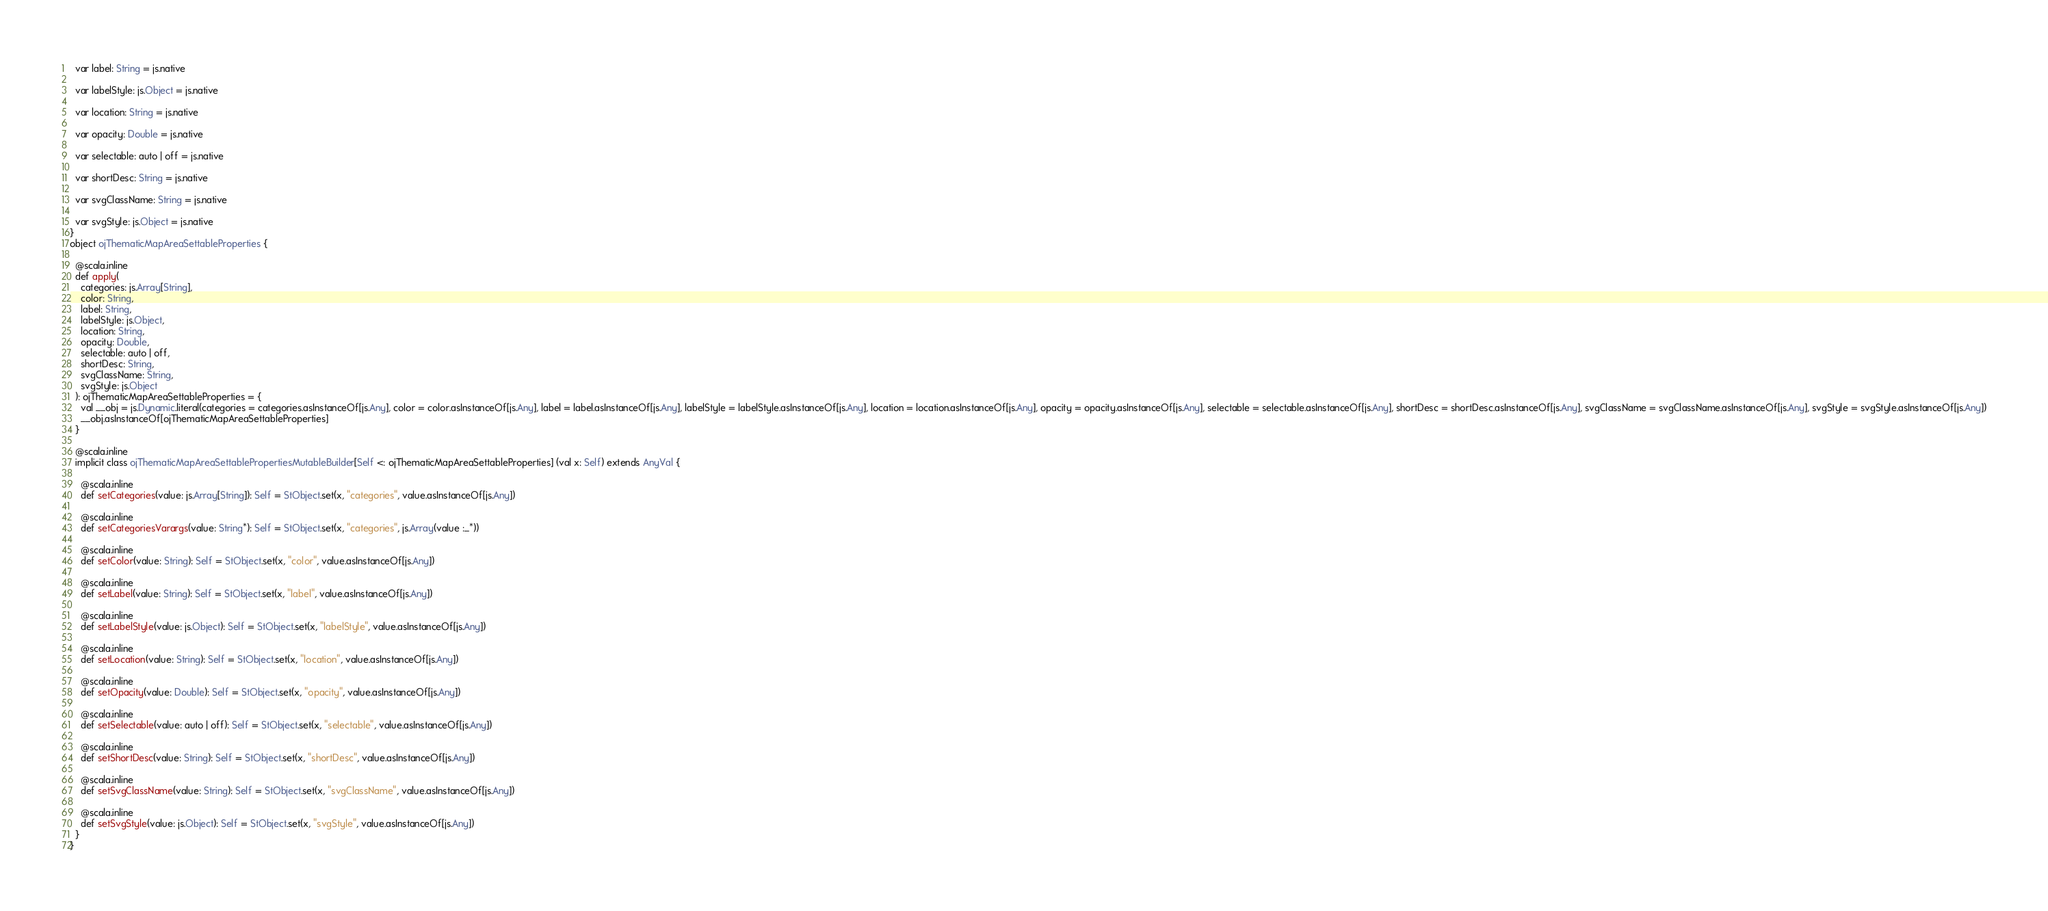<code> <loc_0><loc_0><loc_500><loc_500><_Scala_>  var label: String = js.native
  
  var labelStyle: js.Object = js.native
  
  var location: String = js.native
  
  var opacity: Double = js.native
  
  var selectable: auto | off = js.native
  
  var shortDesc: String = js.native
  
  var svgClassName: String = js.native
  
  var svgStyle: js.Object = js.native
}
object ojThematicMapAreaSettableProperties {
  
  @scala.inline
  def apply(
    categories: js.Array[String],
    color: String,
    label: String,
    labelStyle: js.Object,
    location: String,
    opacity: Double,
    selectable: auto | off,
    shortDesc: String,
    svgClassName: String,
    svgStyle: js.Object
  ): ojThematicMapAreaSettableProperties = {
    val __obj = js.Dynamic.literal(categories = categories.asInstanceOf[js.Any], color = color.asInstanceOf[js.Any], label = label.asInstanceOf[js.Any], labelStyle = labelStyle.asInstanceOf[js.Any], location = location.asInstanceOf[js.Any], opacity = opacity.asInstanceOf[js.Any], selectable = selectable.asInstanceOf[js.Any], shortDesc = shortDesc.asInstanceOf[js.Any], svgClassName = svgClassName.asInstanceOf[js.Any], svgStyle = svgStyle.asInstanceOf[js.Any])
    __obj.asInstanceOf[ojThematicMapAreaSettableProperties]
  }
  
  @scala.inline
  implicit class ojThematicMapAreaSettablePropertiesMutableBuilder[Self <: ojThematicMapAreaSettableProperties] (val x: Self) extends AnyVal {
    
    @scala.inline
    def setCategories(value: js.Array[String]): Self = StObject.set(x, "categories", value.asInstanceOf[js.Any])
    
    @scala.inline
    def setCategoriesVarargs(value: String*): Self = StObject.set(x, "categories", js.Array(value :_*))
    
    @scala.inline
    def setColor(value: String): Self = StObject.set(x, "color", value.asInstanceOf[js.Any])
    
    @scala.inline
    def setLabel(value: String): Self = StObject.set(x, "label", value.asInstanceOf[js.Any])
    
    @scala.inline
    def setLabelStyle(value: js.Object): Self = StObject.set(x, "labelStyle", value.asInstanceOf[js.Any])
    
    @scala.inline
    def setLocation(value: String): Self = StObject.set(x, "location", value.asInstanceOf[js.Any])
    
    @scala.inline
    def setOpacity(value: Double): Self = StObject.set(x, "opacity", value.asInstanceOf[js.Any])
    
    @scala.inline
    def setSelectable(value: auto | off): Self = StObject.set(x, "selectable", value.asInstanceOf[js.Any])
    
    @scala.inline
    def setShortDesc(value: String): Self = StObject.set(x, "shortDesc", value.asInstanceOf[js.Any])
    
    @scala.inline
    def setSvgClassName(value: String): Self = StObject.set(x, "svgClassName", value.asInstanceOf[js.Any])
    
    @scala.inline
    def setSvgStyle(value: js.Object): Self = StObject.set(x, "svgStyle", value.asInstanceOf[js.Any])
  }
}
</code> 